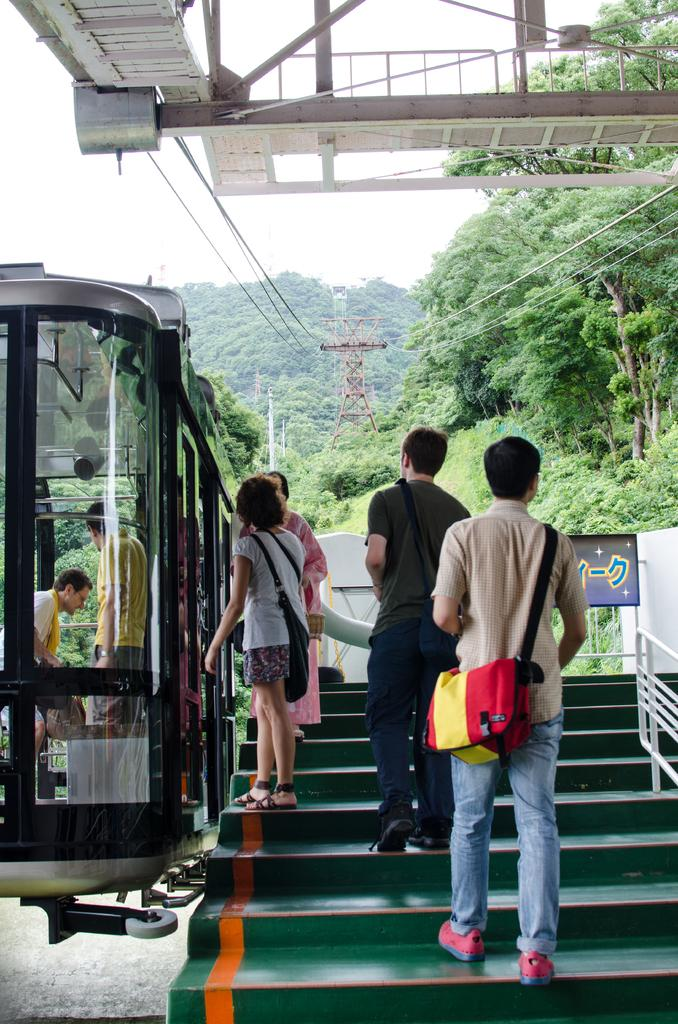What is happening in the image? There are people standing in the image. What are some people wearing in the image? Some people in the image are wearing bags. What type of natural elements can be seen in the image? There are trees in the image. What mode of transportation is present in the image? Cable cars are present in the image. What type of infrastructure is visible in the image? Wires, towers, fencing, and stairs are visible in the image. What is the color of the sky in the image? The sky appears to be white in color. How does the pollution affect the people in the image? There is no mention of pollution in the image, so it cannot be determined how it affects the people. 